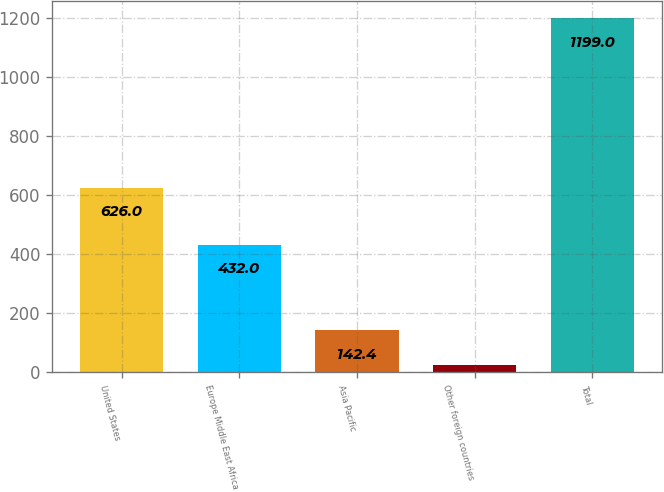<chart> <loc_0><loc_0><loc_500><loc_500><bar_chart><fcel>United States<fcel>Europe Middle East Africa<fcel>Asia Pacific<fcel>Other foreign countries<fcel>Total<nl><fcel>626<fcel>432<fcel>142.4<fcel>25<fcel>1199<nl></chart> 